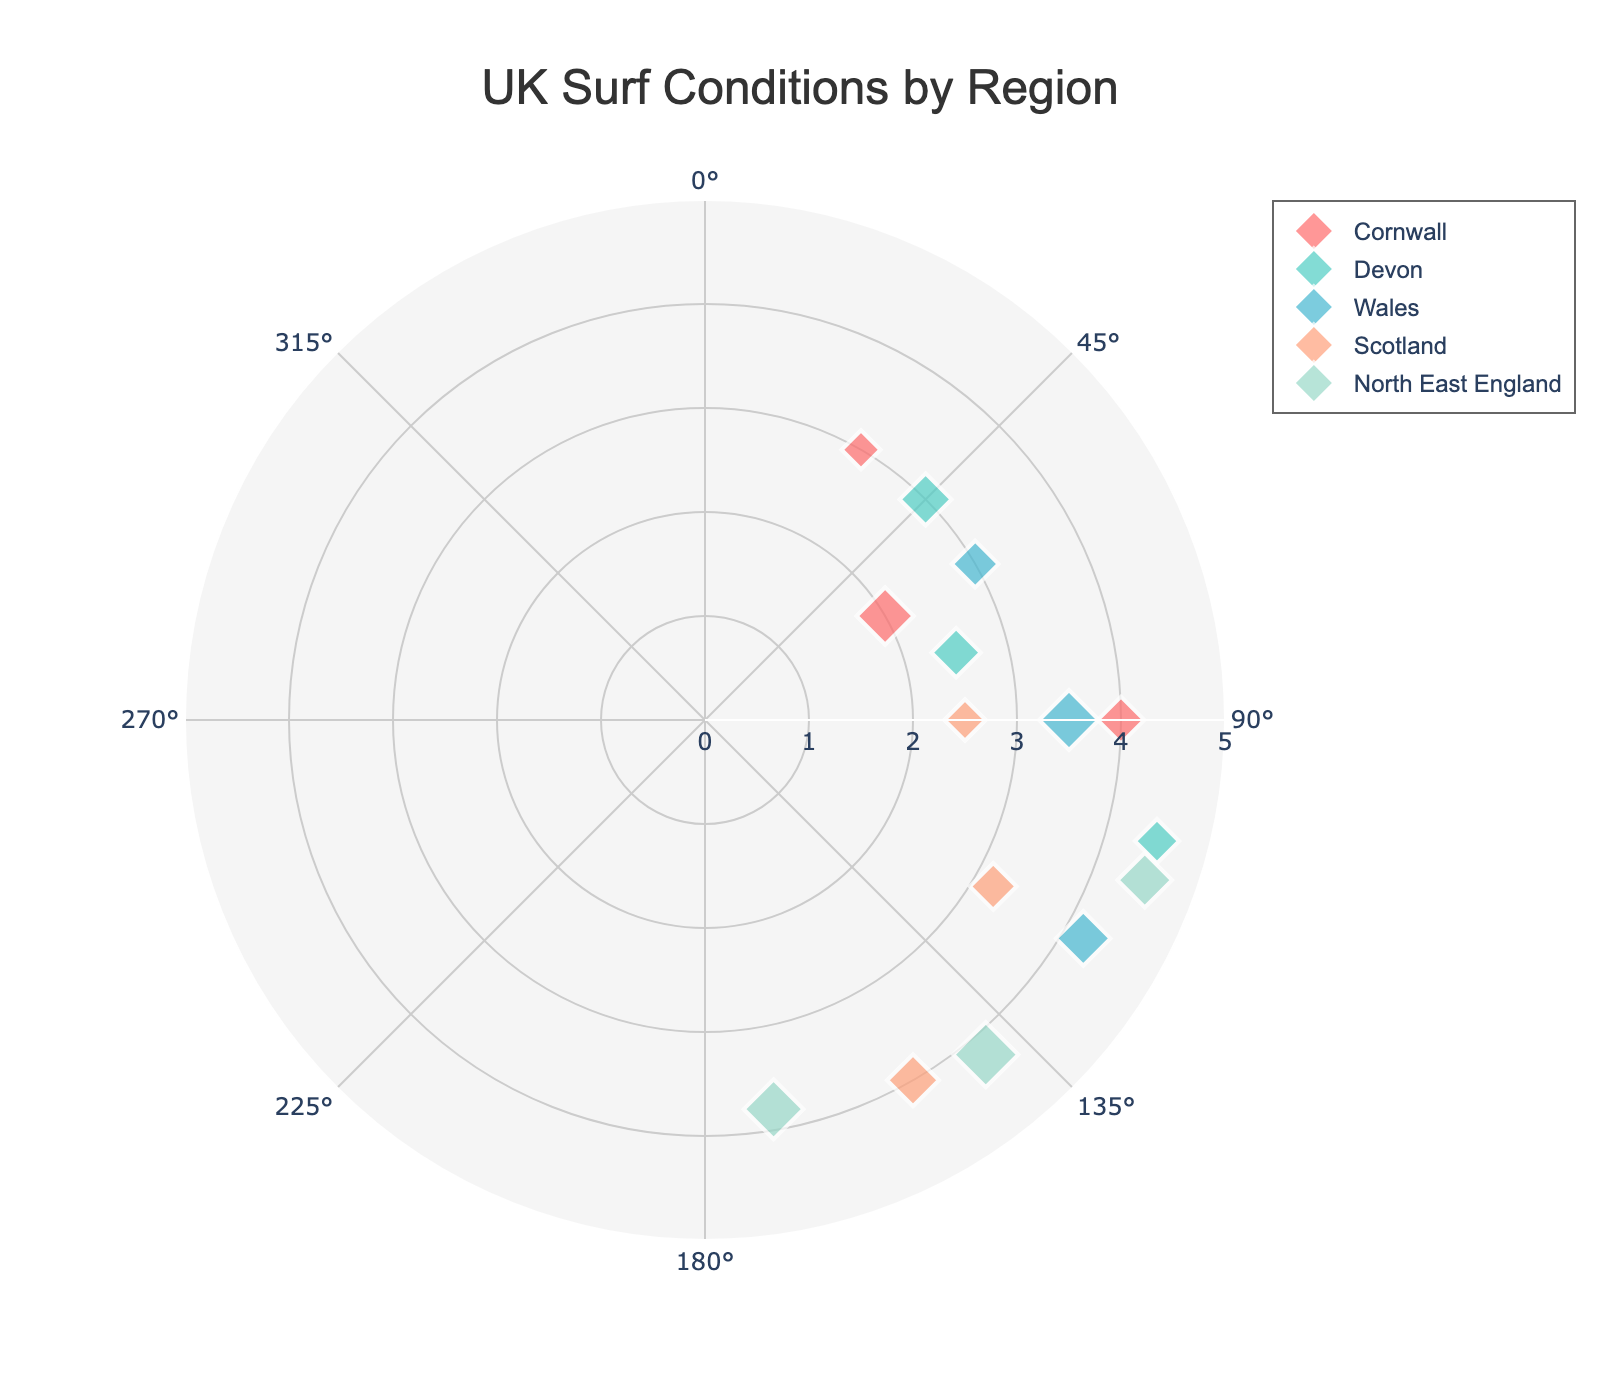Which region has the highest wave height? Inspect the data points and find the maximum wave height value associated with each region. North East England and Devon both have a wave height of 2.5m, the highest value in the chart.
Answer: North East England and Devon What is the average wave height in Cornwall? Look at all the data points for Cornwall and average the wave height values: (1.5 + 2.2 + 1.8) / 3 = 1.83m.
Answer: 1.83m How many regions have wave heights of 2.0m or higher? Check the chart for data points where the wave height is 2.0m or more and count the unique regions associated with them. Cornwall, Devon, Wales, Scotland, and North East England meet this criterion.
Answer: 5 regions Which region has the least variation in wave height values? Examine the data points and determine the range of wave heights for each region. The region with the smallest range (difference between the maximum and minimum wave heights) is Cornwall (range: 0.7m).
Answer: Cornwall Is there any correlation between wave height and water temperature? Observe the size of the markers (indicating wave height) and the hover text for water temperature for each region. Generally, there seems to be no clear visual correlation between wave height and water temperature.
Answer: No clear correlation Are wave heights uniformly distributed across all regions? Look at the distribution of marker sizes across all regions. Some regions, like Cornwall and Devon, have closer wave heights, while others, like Wales and Scotland, show more variation.
Answer: No Which region has the widest range of radial distances (radiuses)? Check the radial axis values for each region. North East England has data points with radiuses ranging from 3.8 to 4.5, making it the region with the widest range.
Answer: North East England How does the wave height in Scotland compare to that in Cornwall? Compare the sizes of the markers for Scotland and Cornwall. Scotland has wave heights between 1.6m and 2.0m, while Cornwall ranges from 1.5m to 2.2m.
Answer: Close Which region has the coolest water temperature? Examine the hover text to find the lowest water temperature value, which is in Scotland (12.0°C).
Answer: Scotland Does any region have all wave height data points exactly the same? Check if any region has data points with identical wave height values. No region satisfies this condition.
Answer: No 